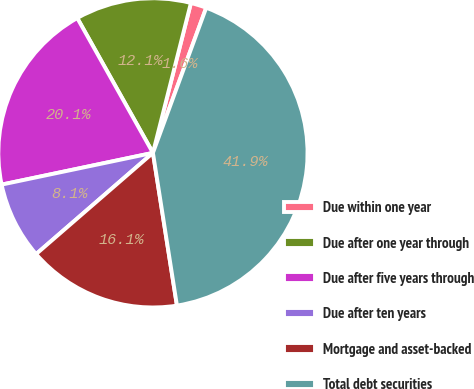<chart> <loc_0><loc_0><loc_500><loc_500><pie_chart><fcel>Due within one year<fcel>Due after one year through<fcel>Due after five years through<fcel>Due after ten years<fcel>Mortgage and asset-backed<fcel>Total debt securities<nl><fcel>1.65%<fcel>12.09%<fcel>20.15%<fcel>8.07%<fcel>16.12%<fcel>41.92%<nl></chart> 